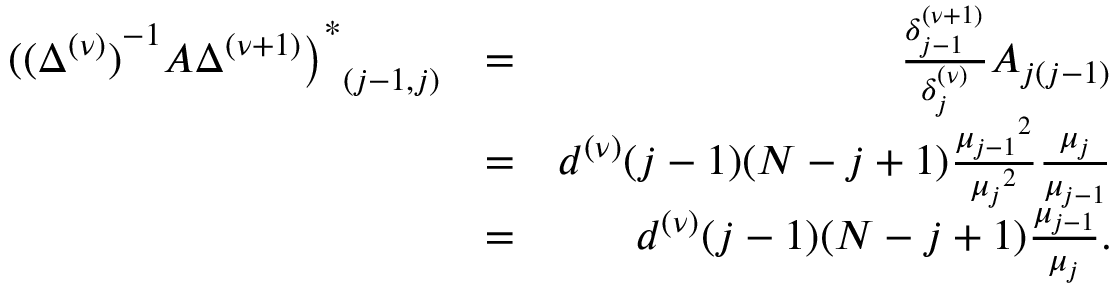Convert formula to latex. <formula><loc_0><loc_0><loc_500><loc_500>\begin{array} { r l r } { { { ( { ( \Delta ^ { ( \nu ) } ) } ^ { - 1 } A \Delta ^ { ( \nu + 1 ) } \Big ) } ^ { \ast } } _ { ( j - 1 , j ) } } & { = } & { \frac { { \delta _ { j - 1 } ^ { ( \nu + 1 ) } } } { \delta _ { j } ^ { ( \nu ) } } A _ { j ( j - 1 ) } } \\ & { = } & { d ^ { ( \nu ) } ( j - 1 ) ( N - j + 1 ) \frac { { \mu _ { j - 1 } } ^ { 2 } } { { \mu _ { j } } ^ { 2 } } \frac { \mu _ { j } } { \mu _ { j - 1 } } } \\ & { = } & { d ^ { ( \nu ) } ( j - 1 ) ( N - j + 1 ) \frac { \mu _ { j - 1 } } { \mu _ { j } } . } \end{array}</formula> 